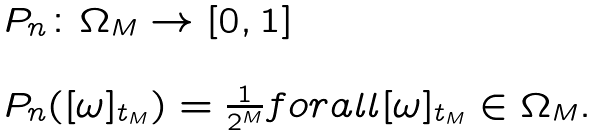<formula> <loc_0><loc_0><loc_500><loc_500>\begin{array} { l l } P _ { n } \colon \Omega _ { M } \rightarrow [ 0 , 1 ] \\ \\ P _ { n } ( [ \omega ] _ { t _ { M } } ) = \frac { 1 } { 2 ^ { M } } f o r a l l [ \omega ] _ { t _ { M } } \in \Omega _ { M } . \end{array}</formula> 